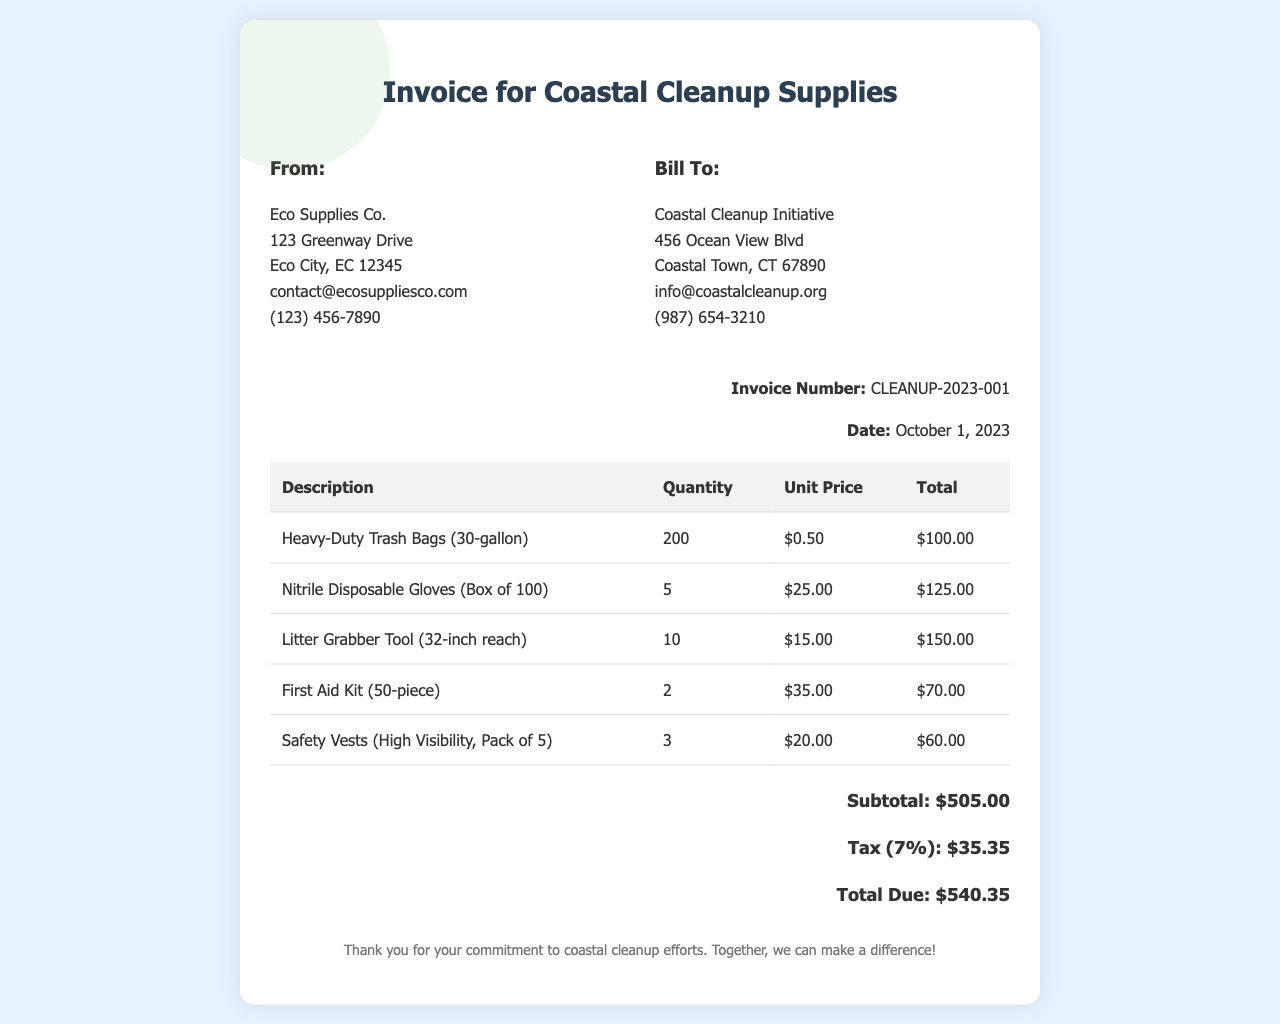What is the invoice number? The invoice number is listed in the invoice details section, which indicates the specific transaction being referenced.
Answer: CLEANUP-2023-001 What is the date of the invoice? The date is mentioned in the invoice details section, indicating when the invoice was issued.
Answer: October 1, 2023 Who is the supplier? The supplier's name and contact information are provided in the header of the invoice.
Answer: Eco Supplies Co What is the total due amount? The total due is presented at the bottom of the invoice, summarizing the overall charges.
Answer: $540.35 How many heavy-duty trash bags were ordered? The quantity of each item is outlined in the table, specifying how many of each item were purchased.
Answer: 200 What is the subtotal amount before tax? The subtotal is identified in the invoice, providing the total cost of items before any taxes are applied.
Answer: $505.00 What is the tax percentage applied to the invoice? The tax rate is indicated next to the tax amount in the totals section of the invoice.
Answer: 7% How many boxes of gloves were ordered? The quantity of gloves is recorded in the itemized list of supplies in the invoice table.
Answer: 5 What is the unit price for the litter grabber tool? The unit price for each item is included in the detailed invoice table, allowing for clear pricing information.
Answer: $15.00 What item is included in the cleanup supplies for first aid? The specific item related to first aid is listed in the itemized table, indicating variety in the supplies offered.
Answer: First Aid Kit (50-piece) 